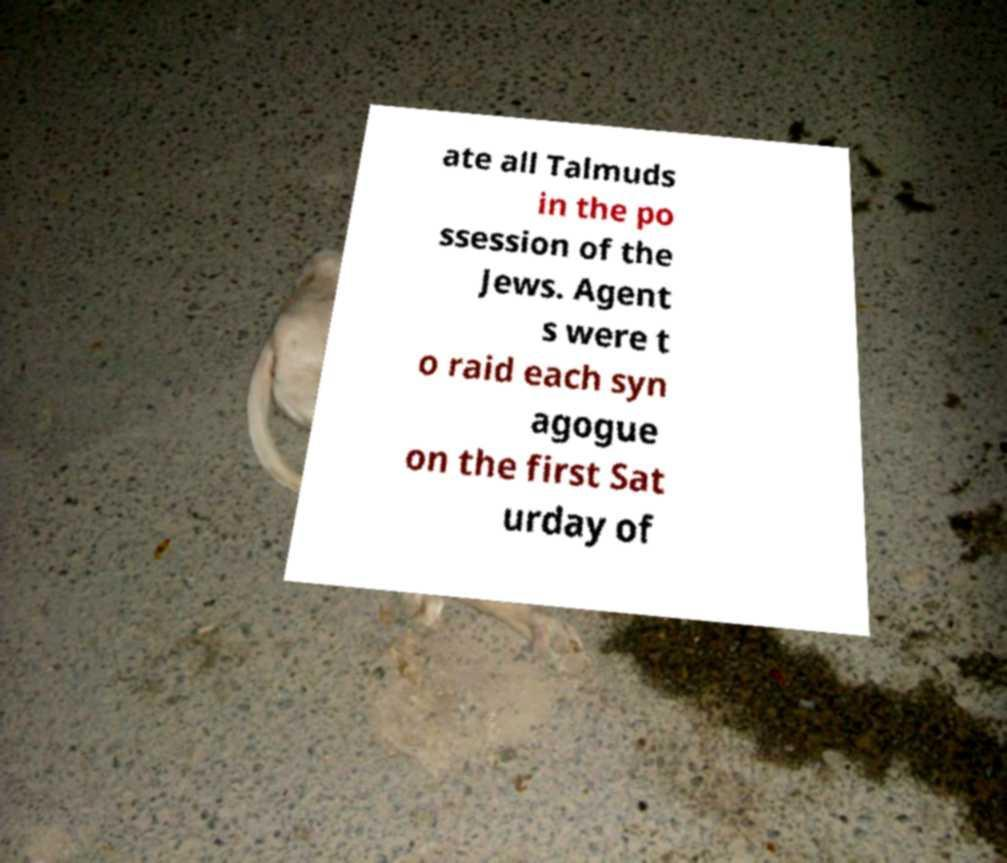There's text embedded in this image that I need extracted. Can you transcribe it verbatim? ate all Talmuds in the po ssession of the Jews. Agent s were t o raid each syn agogue on the first Sat urday of 